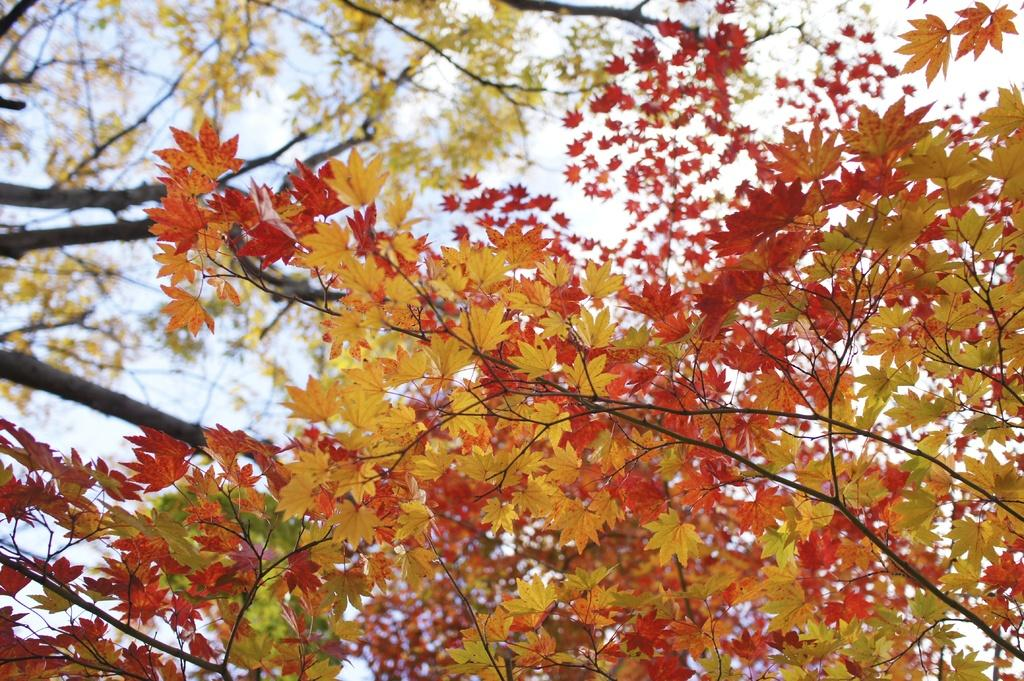What type of vegetation is visible in the image? There are leaves of a tree in the image. What is visible in the background of the image? There is a sky visible in the background of the image. What type of cloth is being used to fly in the image? There is no cloth being used to fly in the image; it only features leaves of a tree and a sky. How does the air move around in the image? The air does not move around in the image; it is stationary. 